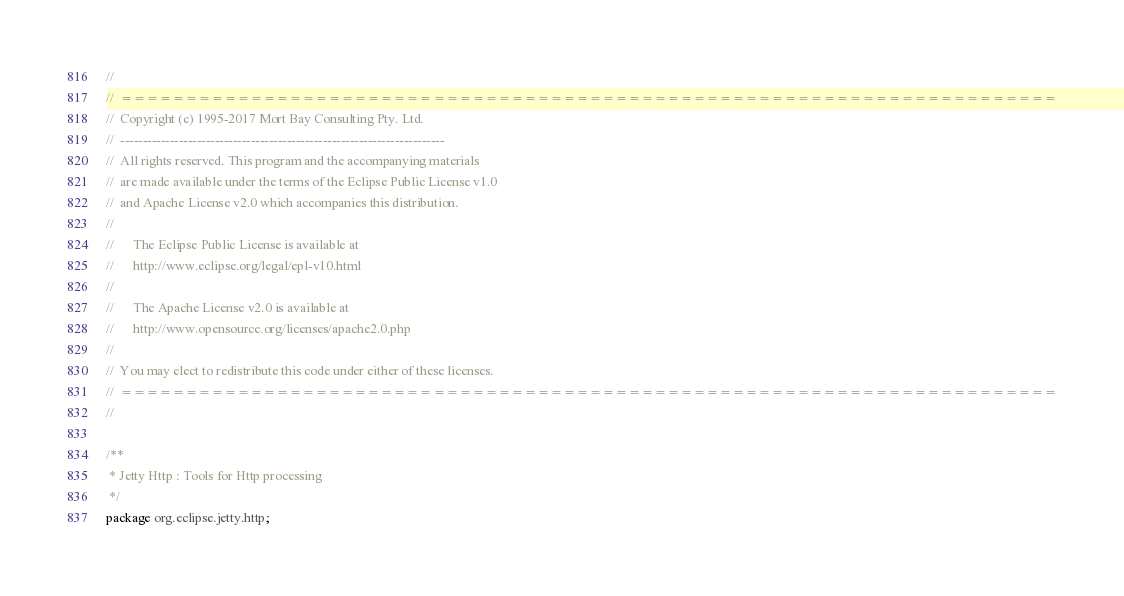Convert code to text. <code><loc_0><loc_0><loc_500><loc_500><_Java_>//
//  ========================================================================
//  Copyright (c) 1995-2017 Mort Bay Consulting Pty. Ltd.
//  ------------------------------------------------------------------------
//  All rights reserved. This program and the accompanying materials
//  are made available under the terms of the Eclipse Public License v1.0
//  and Apache License v2.0 which accompanies this distribution.
//
//      The Eclipse Public License is available at
//      http://www.eclipse.org/legal/epl-v10.html
//
//      The Apache License v2.0 is available at
//      http://www.opensource.org/licenses/apache2.0.php
//
//  You may elect to redistribute this code under either of these licenses.
//  ========================================================================
//

/**
 * Jetty Http : Tools for Http processing
 */
package org.eclipse.jetty.http;

</code> 